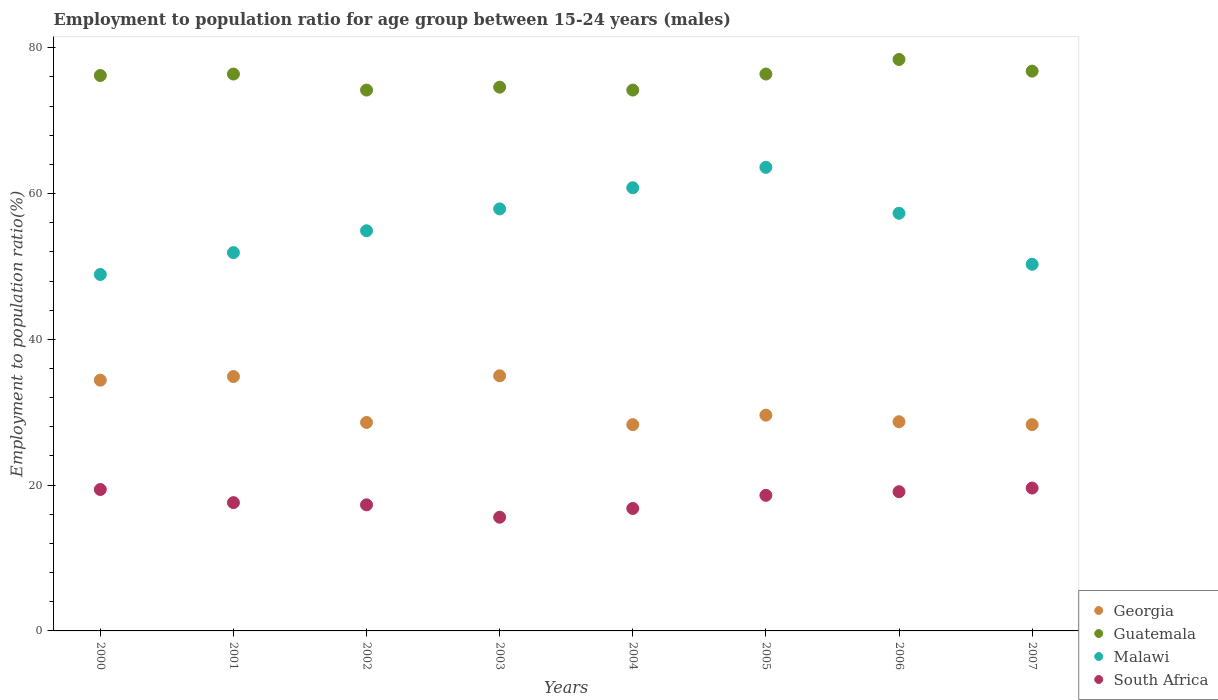Is the number of dotlines equal to the number of legend labels?
Ensure brevity in your answer.  Yes. What is the employment to population ratio in Guatemala in 2005?
Provide a short and direct response. 76.4. Across all years, what is the maximum employment to population ratio in Georgia?
Your response must be concise. 35. Across all years, what is the minimum employment to population ratio in Guatemala?
Provide a succinct answer. 74.2. In which year was the employment to population ratio in Guatemala maximum?
Keep it short and to the point. 2006. In which year was the employment to population ratio in Guatemala minimum?
Your response must be concise. 2002. What is the total employment to population ratio in Malawi in the graph?
Offer a very short reply. 445.6. What is the difference between the employment to population ratio in Malawi in 2004 and that in 2007?
Give a very brief answer. 10.5. What is the difference between the employment to population ratio in South Africa in 2000 and the employment to population ratio in Malawi in 2007?
Provide a short and direct response. -30.9. What is the average employment to population ratio in Malawi per year?
Your answer should be compact. 55.7. In the year 2004, what is the difference between the employment to population ratio in South Africa and employment to population ratio in Guatemala?
Give a very brief answer. -57.4. What is the ratio of the employment to population ratio in Guatemala in 2000 to that in 2005?
Offer a terse response. 1. Is the employment to population ratio in Guatemala in 2001 less than that in 2003?
Your answer should be compact. No. What is the difference between the highest and the second highest employment to population ratio in Georgia?
Keep it short and to the point. 0.1. What is the difference between the highest and the lowest employment to population ratio in South Africa?
Make the answer very short. 4. In how many years, is the employment to population ratio in Guatemala greater than the average employment to population ratio in Guatemala taken over all years?
Offer a terse response. 5. Is the sum of the employment to population ratio in Guatemala in 2001 and 2005 greater than the maximum employment to population ratio in South Africa across all years?
Make the answer very short. Yes. Is it the case that in every year, the sum of the employment to population ratio in Georgia and employment to population ratio in South Africa  is greater than the employment to population ratio in Guatemala?
Your answer should be very brief. No. Does the employment to population ratio in Malawi monotonically increase over the years?
Make the answer very short. No. Is the employment to population ratio in South Africa strictly greater than the employment to population ratio in Malawi over the years?
Give a very brief answer. No. Is the employment to population ratio in Guatemala strictly less than the employment to population ratio in Malawi over the years?
Offer a terse response. No. How many years are there in the graph?
Your answer should be compact. 8. Does the graph contain grids?
Ensure brevity in your answer.  No. Where does the legend appear in the graph?
Your response must be concise. Bottom right. How are the legend labels stacked?
Make the answer very short. Vertical. What is the title of the graph?
Provide a short and direct response. Employment to population ratio for age group between 15-24 years (males). Does "Japan" appear as one of the legend labels in the graph?
Ensure brevity in your answer.  No. What is the label or title of the X-axis?
Offer a very short reply. Years. What is the Employment to population ratio(%) of Georgia in 2000?
Provide a succinct answer. 34.4. What is the Employment to population ratio(%) of Guatemala in 2000?
Provide a short and direct response. 76.2. What is the Employment to population ratio(%) in Malawi in 2000?
Your answer should be very brief. 48.9. What is the Employment to population ratio(%) in South Africa in 2000?
Offer a terse response. 19.4. What is the Employment to population ratio(%) in Georgia in 2001?
Make the answer very short. 34.9. What is the Employment to population ratio(%) in Guatemala in 2001?
Provide a succinct answer. 76.4. What is the Employment to population ratio(%) of Malawi in 2001?
Make the answer very short. 51.9. What is the Employment to population ratio(%) of South Africa in 2001?
Ensure brevity in your answer.  17.6. What is the Employment to population ratio(%) in Georgia in 2002?
Provide a short and direct response. 28.6. What is the Employment to population ratio(%) of Guatemala in 2002?
Offer a terse response. 74.2. What is the Employment to population ratio(%) of Malawi in 2002?
Your response must be concise. 54.9. What is the Employment to population ratio(%) of South Africa in 2002?
Offer a terse response. 17.3. What is the Employment to population ratio(%) of Guatemala in 2003?
Provide a short and direct response. 74.6. What is the Employment to population ratio(%) in Malawi in 2003?
Give a very brief answer. 57.9. What is the Employment to population ratio(%) in South Africa in 2003?
Your answer should be very brief. 15.6. What is the Employment to population ratio(%) of Georgia in 2004?
Provide a succinct answer. 28.3. What is the Employment to population ratio(%) in Guatemala in 2004?
Keep it short and to the point. 74.2. What is the Employment to population ratio(%) of Malawi in 2004?
Provide a succinct answer. 60.8. What is the Employment to population ratio(%) in South Africa in 2004?
Offer a very short reply. 16.8. What is the Employment to population ratio(%) in Georgia in 2005?
Your response must be concise. 29.6. What is the Employment to population ratio(%) of Guatemala in 2005?
Offer a terse response. 76.4. What is the Employment to population ratio(%) in Malawi in 2005?
Keep it short and to the point. 63.6. What is the Employment to population ratio(%) of South Africa in 2005?
Provide a short and direct response. 18.6. What is the Employment to population ratio(%) in Georgia in 2006?
Ensure brevity in your answer.  28.7. What is the Employment to population ratio(%) in Guatemala in 2006?
Your answer should be compact. 78.4. What is the Employment to population ratio(%) in Malawi in 2006?
Provide a succinct answer. 57.3. What is the Employment to population ratio(%) of South Africa in 2006?
Make the answer very short. 19.1. What is the Employment to population ratio(%) in Georgia in 2007?
Give a very brief answer. 28.3. What is the Employment to population ratio(%) of Guatemala in 2007?
Ensure brevity in your answer.  76.8. What is the Employment to population ratio(%) in Malawi in 2007?
Provide a short and direct response. 50.3. What is the Employment to population ratio(%) in South Africa in 2007?
Keep it short and to the point. 19.6. Across all years, what is the maximum Employment to population ratio(%) in Guatemala?
Ensure brevity in your answer.  78.4. Across all years, what is the maximum Employment to population ratio(%) in Malawi?
Give a very brief answer. 63.6. Across all years, what is the maximum Employment to population ratio(%) of South Africa?
Provide a short and direct response. 19.6. Across all years, what is the minimum Employment to population ratio(%) of Georgia?
Your answer should be very brief. 28.3. Across all years, what is the minimum Employment to population ratio(%) of Guatemala?
Give a very brief answer. 74.2. Across all years, what is the minimum Employment to population ratio(%) of Malawi?
Your answer should be compact. 48.9. Across all years, what is the minimum Employment to population ratio(%) in South Africa?
Provide a short and direct response. 15.6. What is the total Employment to population ratio(%) of Georgia in the graph?
Give a very brief answer. 247.8. What is the total Employment to population ratio(%) of Guatemala in the graph?
Keep it short and to the point. 607.2. What is the total Employment to population ratio(%) of Malawi in the graph?
Your answer should be compact. 445.6. What is the total Employment to population ratio(%) of South Africa in the graph?
Your answer should be compact. 144. What is the difference between the Employment to population ratio(%) in Georgia in 2000 and that in 2001?
Give a very brief answer. -0.5. What is the difference between the Employment to population ratio(%) of Malawi in 2000 and that in 2001?
Provide a succinct answer. -3. What is the difference between the Employment to population ratio(%) of South Africa in 2000 and that in 2001?
Make the answer very short. 1.8. What is the difference between the Employment to population ratio(%) of Georgia in 2000 and that in 2002?
Your response must be concise. 5.8. What is the difference between the Employment to population ratio(%) of Malawi in 2000 and that in 2002?
Offer a terse response. -6. What is the difference between the Employment to population ratio(%) of Georgia in 2000 and that in 2003?
Offer a terse response. -0.6. What is the difference between the Employment to population ratio(%) of Malawi in 2000 and that in 2003?
Provide a short and direct response. -9. What is the difference between the Employment to population ratio(%) in Georgia in 2000 and that in 2004?
Provide a short and direct response. 6.1. What is the difference between the Employment to population ratio(%) of Guatemala in 2000 and that in 2004?
Your answer should be compact. 2. What is the difference between the Employment to population ratio(%) of Malawi in 2000 and that in 2004?
Your answer should be compact. -11.9. What is the difference between the Employment to population ratio(%) of Georgia in 2000 and that in 2005?
Offer a very short reply. 4.8. What is the difference between the Employment to population ratio(%) of Malawi in 2000 and that in 2005?
Offer a terse response. -14.7. What is the difference between the Employment to population ratio(%) of South Africa in 2000 and that in 2005?
Your answer should be very brief. 0.8. What is the difference between the Employment to population ratio(%) in Guatemala in 2000 and that in 2006?
Offer a very short reply. -2.2. What is the difference between the Employment to population ratio(%) in South Africa in 2000 and that in 2006?
Offer a very short reply. 0.3. What is the difference between the Employment to population ratio(%) of Guatemala in 2000 and that in 2007?
Give a very brief answer. -0.6. What is the difference between the Employment to population ratio(%) of South Africa in 2000 and that in 2007?
Keep it short and to the point. -0.2. What is the difference between the Employment to population ratio(%) in Guatemala in 2001 and that in 2002?
Your answer should be very brief. 2.2. What is the difference between the Employment to population ratio(%) in Malawi in 2001 and that in 2002?
Make the answer very short. -3. What is the difference between the Employment to population ratio(%) of South Africa in 2001 and that in 2002?
Keep it short and to the point. 0.3. What is the difference between the Employment to population ratio(%) in Georgia in 2001 and that in 2003?
Make the answer very short. -0.1. What is the difference between the Employment to population ratio(%) of Malawi in 2001 and that in 2003?
Make the answer very short. -6. What is the difference between the Employment to population ratio(%) in Georgia in 2001 and that in 2004?
Your answer should be very brief. 6.6. What is the difference between the Employment to population ratio(%) in South Africa in 2001 and that in 2004?
Ensure brevity in your answer.  0.8. What is the difference between the Employment to population ratio(%) of Georgia in 2001 and that in 2005?
Keep it short and to the point. 5.3. What is the difference between the Employment to population ratio(%) in Malawi in 2001 and that in 2005?
Your response must be concise. -11.7. What is the difference between the Employment to population ratio(%) of Guatemala in 2001 and that in 2006?
Your response must be concise. -2. What is the difference between the Employment to population ratio(%) in Malawi in 2001 and that in 2006?
Your answer should be compact. -5.4. What is the difference between the Employment to population ratio(%) of Guatemala in 2001 and that in 2007?
Keep it short and to the point. -0.4. What is the difference between the Employment to population ratio(%) of Georgia in 2002 and that in 2003?
Make the answer very short. -6.4. What is the difference between the Employment to population ratio(%) of Guatemala in 2002 and that in 2003?
Provide a short and direct response. -0.4. What is the difference between the Employment to population ratio(%) in Malawi in 2002 and that in 2003?
Your answer should be very brief. -3. What is the difference between the Employment to population ratio(%) in South Africa in 2002 and that in 2003?
Provide a succinct answer. 1.7. What is the difference between the Employment to population ratio(%) in Malawi in 2002 and that in 2004?
Make the answer very short. -5.9. What is the difference between the Employment to population ratio(%) of South Africa in 2002 and that in 2004?
Give a very brief answer. 0.5. What is the difference between the Employment to population ratio(%) in Guatemala in 2002 and that in 2005?
Give a very brief answer. -2.2. What is the difference between the Employment to population ratio(%) in Malawi in 2002 and that in 2005?
Ensure brevity in your answer.  -8.7. What is the difference between the Employment to population ratio(%) in South Africa in 2002 and that in 2005?
Ensure brevity in your answer.  -1.3. What is the difference between the Employment to population ratio(%) of Georgia in 2002 and that in 2006?
Your answer should be very brief. -0.1. What is the difference between the Employment to population ratio(%) of Guatemala in 2002 and that in 2006?
Provide a short and direct response. -4.2. What is the difference between the Employment to population ratio(%) in Georgia in 2002 and that in 2007?
Ensure brevity in your answer.  0.3. What is the difference between the Employment to population ratio(%) of Guatemala in 2002 and that in 2007?
Your answer should be compact. -2.6. What is the difference between the Employment to population ratio(%) in Malawi in 2002 and that in 2007?
Offer a terse response. 4.6. What is the difference between the Employment to population ratio(%) of Malawi in 2003 and that in 2004?
Your answer should be compact. -2.9. What is the difference between the Employment to population ratio(%) of Georgia in 2003 and that in 2005?
Provide a succinct answer. 5.4. What is the difference between the Employment to population ratio(%) in Guatemala in 2003 and that in 2005?
Provide a succinct answer. -1.8. What is the difference between the Employment to population ratio(%) of Malawi in 2003 and that in 2005?
Make the answer very short. -5.7. What is the difference between the Employment to population ratio(%) in Guatemala in 2003 and that in 2006?
Offer a terse response. -3.8. What is the difference between the Employment to population ratio(%) in South Africa in 2003 and that in 2006?
Ensure brevity in your answer.  -3.5. What is the difference between the Employment to population ratio(%) in Georgia in 2003 and that in 2007?
Ensure brevity in your answer.  6.7. What is the difference between the Employment to population ratio(%) of Malawi in 2003 and that in 2007?
Offer a very short reply. 7.6. What is the difference between the Employment to population ratio(%) of Georgia in 2004 and that in 2005?
Offer a terse response. -1.3. What is the difference between the Employment to population ratio(%) in Guatemala in 2004 and that in 2005?
Offer a very short reply. -2.2. What is the difference between the Employment to population ratio(%) in South Africa in 2004 and that in 2005?
Your response must be concise. -1.8. What is the difference between the Employment to population ratio(%) of Georgia in 2004 and that in 2006?
Provide a short and direct response. -0.4. What is the difference between the Employment to population ratio(%) of Malawi in 2004 and that in 2006?
Provide a succinct answer. 3.5. What is the difference between the Employment to population ratio(%) of South Africa in 2004 and that in 2007?
Give a very brief answer. -2.8. What is the difference between the Employment to population ratio(%) of Georgia in 2005 and that in 2006?
Your response must be concise. 0.9. What is the difference between the Employment to population ratio(%) in Guatemala in 2005 and that in 2006?
Your answer should be very brief. -2. What is the difference between the Employment to population ratio(%) of Malawi in 2005 and that in 2006?
Keep it short and to the point. 6.3. What is the difference between the Employment to population ratio(%) in Georgia in 2005 and that in 2007?
Your response must be concise. 1.3. What is the difference between the Employment to population ratio(%) in Georgia in 2006 and that in 2007?
Give a very brief answer. 0.4. What is the difference between the Employment to population ratio(%) in Guatemala in 2006 and that in 2007?
Your response must be concise. 1.6. What is the difference between the Employment to population ratio(%) in Malawi in 2006 and that in 2007?
Provide a short and direct response. 7. What is the difference between the Employment to population ratio(%) of Georgia in 2000 and the Employment to population ratio(%) of Guatemala in 2001?
Provide a succinct answer. -42. What is the difference between the Employment to population ratio(%) in Georgia in 2000 and the Employment to population ratio(%) in Malawi in 2001?
Offer a terse response. -17.5. What is the difference between the Employment to population ratio(%) in Guatemala in 2000 and the Employment to population ratio(%) in Malawi in 2001?
Keep it short and to the point. 24.3. What is the difference between the Employment to population ratio(%) of Guatemala in 2000 and the Employment to population ratio(%) of South Africa in 2001?
Ensure brevity in your answer.  58.6. What is the difference between the Employment to population ratio(%) of Malawi in 2000 and the Employment to population ratio(%) of South Africa in 2001?
Offer a very short reply. 31.3. What is the difference between the Employment to population ratio(%) of Georgia in 2000 and the Employment to population ratio(%) of Guatemala in 2002?
Provide a succinct answer. -39.8. What is the difference between the Employment to population ratio(%) in Georgia in 2000 and the Employment to population ratio(%) in Malawi in 2002?
Ensure brevity in your answer.  -20.5. What is the difference between the Employment to population ratio(%) in Guatemala in 2000 and the Employment to population ratio(%) in Malawi in 2002?
Your answer should be compact. 21.3. What is the difference between the Employment to population ratio(%) of Guatemala in 2000 and the Employment to population ratio(%) of South Africa in 2002?
Give a very brief answer. 58.9. What is the difference between the Employment to population ratio(%) in Malawi in 2000 and the Employment to population ratio(%) in South Africa in 2002?
Make the answer very short. 31.6. What is the difference between the Employment to population ratio(%) in Georgia in 2000 and the Employment to population ratio(%) in Guatemala in 2003?
Offer a terse response. -40.2. What is the difference between the Employment to population ratio(%) of Georgia in 2000 and the Employment to population ratio(%) of Malawi in 2003?
Your response must be concise. -23.5. What is the difference between the Employment to population ratio(%) of Georgia in 2000 and the Employment to population ratio(%) of South Africa in 2003?
Offer a very short reply. 18.8. What is the difference between the Employment to population ratio(%) of Guatemala in 2000 and the Employment to population ratio(%) of South Africa in 2003?
Provide a succinct answer. 60.6. What is the difference between the Employment to population ratio(%) in Malawi in 2000 and the Employment to population ratio(%) in South Africa in 2003?
Ensure brevity in your answer.  33.3. What is the difference between the Employment to population ratio(%) in Georgia in 2000 and the Employment to population ratio(%) in Guatemala in 2004?
Ensure brevity in your answer.  -39.8. What is the difference between the Employment to population ratio(%) of Georgia in 2000 and the Employment to population ratio(%) of Malawi in 2004?
Your answer should be very brief. -26.4. What is the difference between the Employment to population ratio(%) of Guatemala in 2000 and the Employment to population ratio(%) of Malawi in 2004?
Provide a succinct answer. 15.4. What is the difference between the Employment to population ratio(%) in Guatemala in 2000 and the Employment to population ratio(%) in South Africa in 2004?
Give a very brief answer. 59.4. What is the difference between the Employment to population ratio(%) in Malawi in 2000 and the Employment to population ratio(%) in South Africa in 2004?
Make the answer very short. 32.1. What is the difference between the Employment to population ratio(%) in Georgia in 2000 and the Employment to population ratio(%) in Guatemala in 2005?
Ensure brevity in your answer.  -42. What is the difference between the Employment to population ratio(%) of Georgia in 2000 and the Employment to population ratio(%) of Malawi in 2005?
Give a very brief answer. -29.2. What is the difference between the Employment to population ratio(%) in Guatemala in 2000 and the Employment to population ratio(%) in South Africa in 2005?
Give a very brief answer. 57.6. What is the difference between the Employment to population ratio(%) of Malawi in 2000 and the Employment to population ratio(%) of South Africa in 2005?
Your answer should be compact. 30.3. What is the difference between the Employment to population ratio(%) of Georgia in 2000 and the Employment to population ratio(%) of Guatemala in 2006?
Give a very brief answer. -44. What is the difference between the Employment to population ratio(%) of Georgia in 2000 and the Employment to population ratio(%) of Malawi in 2006?
Offer a very short reply. -22.9. What is the difference between the Employment to population ratio(%) in Georgia in 2000 and the Employment to population ratio(%) in South Africa in 2006?
Ensure brevity in your answer.  15.3. What is the difference between the Employment to population ratio(%) of Guatemala in 2000 and the Employment to population ratio(%) of South Africa in 2006?
Ensure brevity in your answer.  57.1. What is the difference between the Employment to population ratio(%) in Malawi in 2000 and the Employment to population ratio(%) in South Africa in 2006?
Offer a terse response. 29.8. What is the difference between the Employment to population ratio(%) of Georgia in 2000 and the Employment to population ratio(%) of Guatemala in 2007?
Provide a succinct answer. -42.4. What is the difference between the Employment to population ratio(%) in Georgia in 2000 and the Employment to population ratio(%) in Malawi in 2007?
Your answer should be compact. -15.9. What is the difference between the Employment to population ratio(%) in Guatemala in 2000 and the Employment to population ratio(%) in Malawi in 2007?
Your response must be concise. 25.9. What is the difference between the Employment to population ratio(%) of Guatemala in 2000 and the Employment to population ratio(%) of South Africa in 2007?
Provide a short and direct response. 56.6. What is the difference between the Employment to population ratio(%) in Malawi in 2000 and the Employment to population ratio(%) in South Africa in 2007?
Ensure brevity in your answer.  29.3. What is the difference between the Employment to population ratio(%) in Georgia in 2001 and the Employment to population ratio(%) in Guatemala in 2002?
Your response must be concise. -39.3. What is the difference between the Employment to population ratio(%) of Georgia in 2001 and the Employment to population ratio(%) of Malawi in 2002?
Your response must be concise. -20. What is the difference between the Employment to population ratio(%) in Guatemala in 2001 and the Employment to population ratio(%) in Malawi in 2002?
Offer a very short reply. 21.5. What is the difference between the Employment to population ratio(%) of Guatemala in 2001 and the Employment to population ratio(%) of South Africa in 2002?
Your answer should be compact. 59.1. What is the difference between the Employment to population ratio(%) of Malawi in 2001 and the Employment to population ratio(%) of South Africa in 2002?
Provide a succinct answer. 34.6. What is the difference between the Employment to population ratio(%) of Georgia in 2001 and the Employment to population ratio(%) of Guatemala in 2003?
Provide a short and direct response. -39.7. What is the difference between the Employment to population ratio(%) in Georgia in 2001 and the Employment to population ratio(%) in Malawi in 2003?
Your answer should be compact. -23. What is the difference between the Employment to population ratio(%) in Georgia in 2001 and the Employment to population ratio(%) in South Africa in 2003?
Keep it short and to the point. 19.3. What is the difference between the Employment to population ratio(%) of Guatemala in 2001 and the Employment to population ratio(%) of South Africa in 2003?
Your response must be concise. 60.8. What is the difference between the Employment to population ratio(%) in Malawi in 2001 and the Employment to population ratio(%) in South Africa in 2003?
Your response must be concise. 36.3. What is the difference between the Employment to population ratio(%) of Georgia in 2001 and the Employment to population ratio(%) of Guatemala in 2004?
Keep it short and to the point. -39.3. What is the difference between the Employment to population ratio(%) of Georgia in 2001 and the Employment to population ratio(%) of Malawi in 2004?
Make the answer very short. -25.9. What is the difference between the Employment to population ratio(%) in Georgia in 2001 and the Employment to population ratio(%) in South Africa in 2004?
Ensure brevity in your answer.  18.1. What is the difference between the Employment to population ratio(%) in Guatemala in 2001 and the Employment to population ratio(%) in South Africa in 2004?
Your response must be concise. 59.6. What is the difference between the Employment to population ratio(%) of Malawi in 2001 and the Employment to population ratio(%) of South Africa in 2004?
Provide a short and direct response. 35.1. What is the difference between the Employment to population ratio(%) of Georgia in 2001 and the Employment to population ratio(%) of Guatemala in 2005?
Provide a short and direct response. -41.5. What is the difference between the Employment to population ratio(%) of Georgia in 2001 and the Employment to population ratio(%) of Malawi in 2005?
Make the answer very short. -28.7. What is the difference between the Employment to population ratio(%) of Guatemala in 2001 and the Employment to population ratio(%) of South Africa in 2005?
Provide a short and direct response. 57.8. What is the difference between the Employment to population ratio(%) in Malawi in 2001 and the Employment to population ratio(%) in South Africa in 2005?
Give a very brief answer. 33.3. What is the difference between the Employment to population ratio(%) in Georgia in 2001 and the Employment to population ratio(%) in Guatemala in 2006?
Offer a terse response. -43.5. What is the difference between the Employment to population ratio(%) of Georgia in 2001 and the Employment to population ratio(%) of Malawi in 2006?
Keep it short and to the point. -22.4. What is the difference between the Employment to population ratio(%) of Georgia in 2001 and the Employment to population ratio(%) of South Africa in 2006?
Your response must be concise. 15.8. What is the difference between the Employment to population ratio(%) of Guatemala in 2001 and the Employment to population ratio(%) of Malawi in 2006?
Offer a very short reply. 19.1. What is the difference between the Employment to population ratio(%) in Guatemala in 2001 and the Employment to population ratio(%) in South Africa in 2006?
Provide a short and direct response. 57.3. What is the difference between the Employment to population ratio(%) in Malawi in 2001 and the Employment to population ratio(%) in South Africa in 2006?
Keep it short and to the point. 32.8. What is the difference between the Employment to population ratio(%) in Georgia in 2001 and the Employment to population ratio(%) in Guatemala in 2007?
Ensure brevity in your answer.  -41.9. What is the difference between the Employment to population ratio(%) in Georgia in 2001 and the Employment to population ratio(%) in Malawi in 2007?
Give a very brief answer. -15.4. What is the difference between the Employment to population ratio(%) in Georgia in 2001 and the Employment to population ratio(%) in South Africa in 2007?
Your answer should be compact. 15.3. What is the difference between the Employment to population ratio(%) in Guatemala in 2001 and the Employment to population ratio(%) in Malawi in 2007?
Ensure brevity in your answer.  26.1. What is the difference between the Employment to population ratio(%) in Guatemala in 2001 and the Employment to population ratio(%) in South Africa in 2007?
Offer a very short reply. 56.8. What is the difference between the Employment to population ratio(%) in Malawi in 2001 and the Employment to population ratio(%) in South Africa in 2007?
Keep it short and to the point. 32.3. What is the difference between the Employment to population ratio(%) of Georgia in 2002 and the Employment to population ratio(%) of Guatemala in 2003?
Offer a terse response. -46. What is the difference between the Employment to population ratio(%) of Georgia in 2002 and the Employment to population ratio(%) of Malawi in 2003?
Provide a short and direct response. -29.3. What is the difference between the Employment to population ratio(%) of Georgia in 2002 and the Employment to population ratio(%) of South Africa in 2003?
Offer a very short reply. 13. What is the difference between the Employment to population ratio(%) of Guatemala in 2002 and the Employment to population ratio(%) of Malawi in 2003?
Your response must be concise. 16.3. What is the difference between the Employment to population ratio(%) of Guatemala in 2002 and the Employment to population ratio(%) of South Africa in 2003?
Provide a succinct answer. 58.6. What is the difference between the Employment to population ratio(%) in Malawi in 2002 and the Employment to population ratio(%) in South Africa in 2003?
Your answer should be very brief. 39.3. What is the difference between the Employment to population ratio(%) of Georgia in 2002 and the Employment to population ratio(%) of Guatemala in 2004?
Give a very brief answer. -45.6. What is the difference between the Employment to population ratio(%) in Georgia in 2002 and the Employment to population ratio(%) in Malawi in 2004?
Ensure brevity in your answer.  -32.2. What is the difference between the Employment to population ratio(%) of Georgia in 2002 and the Employment to population ratio(%) of South Africa in 2004?
Your response must be concise. 11.8. What is the difference between the Employment to population ratio(%) in Guatemala in 2002 and the Employment to population ratio(%) in South Africa in 2004?
Provide a succinct answer. 57.4. What is the difference between the Employment to population ratio(%) in Malawi in 2002 and the Employment to population ratio(%) in South Africa in 2004?
Your answer should be very brief. 38.1. What is the difference between the Employment to population ratio(%) of Georgia in 2002 and the Employment to population ratio(%) of Guatemala in 2005?
Provide a short and direct response. -47.8. What is the difference between the Employment to population ratio(%) in Georgia in 2002 and the Employment to population ratio(%) in Malawi in 2005?
Make the answer very short. -35. What is the difference between the Employment to population ratio(%) of Georgia in 2002 and the Employment to population ratio(%) of South Africa in 2005?
Provide a short and direct response. 10. What is the difference between the Employment to population ratio(%) in Guatemala in 2002 and the Employment to population ratio(%) in South Africa in 2005?
Provide a succinct answer. 55.6. What is the difference between the Employment to population ratio(%) of Malawi in 2002 and the Employment to population ratio(%) of South Africa in 2005?
Make the answer very short. 36.3. What is the difference between the Employment to population ratio(%) of Georgia in 2002 and the Employment to population ratio(%) of Guatemala in 2006?
Your response must be concise. -49.8. What is the difference between the Employment to population ratio(%) of Georgia in 2002 and the Employment to population ratio(%) of Malawi in 2006?
Provide a short and direct response. -28.7. What is the difference between the Employment to population ratio(%) of Georgia in 2002 and the Employment to population ratio(%) of South Africa in 2006?
Keep it short and to the point. 9.5. What is the difference between the Employment to population ratio(%) of Guatemala in 2002 and the Employment to population ratio(%) of South Africa in 2006?
Provide a succinct answer. 55.1. What is the difference between the Employment to population ratio(%) of Malawi in 2002 and the Employment to population ratio(%) of South Africa in 2006?
Provide a short and direct response. 35.8. What is the difference between the Employment to population ratio(%) of Georgia in 2002 and the Employment to population ratio(%) of Guatemala in 2007?
Keep it short and to the point. -48.2. What is the difference between the Employment to population ratio(%) in Georgia in 2002 and the Employment to population ratio(%) in Malawi in 2007?
Offer a terse response. -21.7. What is the difference between the Employment to population ratio(%) in Georgia in 2002 and the Employment to population ratio(%) in South Africa in 2007?
Offer a terse response. 9. What is the difference between the Employment to population ratio(%) in Guatemala in 2002 and the Employment to population ratio(%) in Malawi in 2007?
Your answer should be compact. 23.9. What is the difference between the Employment to population ratio(%) of Guatemala in 2002 and the Employment to population ratio(%) of South Africa in 2007?
Your response must be concise. 54.6. What is the difference between the Employment to population ratio(%) in Malawi in 2002 and the Employment to population ratio(%) in South Africa in 2007?
Make the answer very short. 35.3. What is the difference between the Employment to population ratio(%) of Georgia in 2003 and the Employment to population ratio(%) of Guatemala in 2004?
Your response must be concise. -39.2. What is the difference between the Employment to population ratio(%) of Georgia in 2003 and the Employment to population ratio(%) of Malawi in 2004?
Your answer should be compact. -25.8. What is the difference between the Employment to population ratio(%) in Guatemala in 2003 and the Employment to population ratio(%) in South Africa in 2004?
Offer a very short reply. 57.8. What is the difference between the Employment to population ratio(%) in Malawi in 2003 and the Employment to population ratio(%) in South Africa in 2004?
Offer a very short reply. 41.1. What is the difference between the Employment to population ratio(%) in Georgia in 2003 and the Employment to population ratio(%) in Guatemala in 2005?
Your answer should be compact. -41.4. What is the difference between the Employment to population ratio(%) of Georgia in 2003 and the Employment to population ratio(%) of Malawi in 2005?
Your response must be concise. -28.6. What is the difference between the Employment to population ratio(%) of Georgia in 2003 and the Employment to population ratio(%) of South Africa in 2005?
Provide a short and direct response. 16.4. What is the difference between the Employment to population ratio(%) in Guatemala in 2003 and the Employment to population ratio(%) in Malawi in 2005?
Keep it short and to the point. 11. What is the difference between the Employment to population ratio(%) of Guatemala in 2003 and the Employment to population ratio(%) of South Africa in 2005?
Provide a short and direct response. 56. What is the difference between the Employment to population ratio(%) in Malawi in 2003 and the Employment to population ratio(%) in South Africa in 2005?
Offer a terse response. 39.3. What is the difference between the Employment to population ratio(%) of Georgia in 2003 and the Employment to population ratio(%) of Guatemala in 2006?
Provide a short and direct response. -43.4. What is the difference between the Employment to population ratio(%) in Georgia in 2003 and the Employment to population ratio(%) in Malawi in 2006?
Provide a short and direct response. -22.3. What is the difference between the Employment to population ratio(%) of Georgia in 2003 and the Employment to population ratio(%) of South Africa in 2006?
Give a very brief answer. 15.9. What is the difference between the Employment to population ratio(%) of Guatemala in 2003 and the Employment to population ratio(%) of South Africa in 2006?
Offer a very short reply. 55.5. What is the difference between the Employment to population ratio(%) of Malawi in 2003 and the Employment to population ratio(%) of South Africa in 2006?
Offer a terse response. 38.8. What is the difference between the Employment to population ratio(%) of Georgia in 2003 and the Employment to population ratio(%) of Guatemala in 2007?
Make the answer very short. -41.8. What is the difference between the Employment to population ratio(%) in Georgia in 2003 and the Employment to population ratio(%) in Malawi in 2007?
Make the answer very short. -15.3. What is the difference between the Employment to population ratio(%) of Georgia in 2003 and the Employment to population ratio(%) of South Africa in 2007?
Provide a short and direct response. 15.4. What is the difference between the Employment to population ratio(%) in Guatemala in 2003 and the Employment to population ratio(%) in Malawi in 2007?
Keep it short and to the point. 24.3. What is the difference between the Employment to population ratio(%) of Guatemala in 2003 and the Employment to population ratio(%) of South Africa in 2007?
Ensure brevity in your answer.  55. What is the difference between the Employment to population ratio(%) in Malawi in 2003 and the Employment to population ratio(%) in South Africa in 2007?
Your answer should be compact. 38.3. What is the difference between the Employment to population ratio(%) in Georgia in 2004 and the Employment to population ratio(%) in Guatemala in 2005?
Your answer should be compact. -48.1. What is the difference between the Employment to population ratio(%) of Georgia in 2004 and the Employment to population ratio(%) of Malawi in 2005?
Offer a terse response. -35.3. What is the difference between the Employment to population ratio(%) in Georgia in 2004 and the Employment to population ratio(%) in South Africa in 2005?
Provide a short and direct response. 9.7. What is the difference between the Employment to population ratio(%) of Guatemala in 2004 and the Employment to population ratio(%) of South Africa in 2005?
Offer a terse response. 55.6. What is the difference between the Employment to population ratio(%) of Malawi in 2004 and the Employment to population ratio(%) of South Africa in 2005?
Provide a short and direct response. 42.2. What is the difference between the Employment to population ratio(%) in Georgia in 2004 and the Employment to population ratio(%) in Guatemala in 2006?
Give a very brief answer. -50.1. What is the difference between the Employment to population ratio(%) of Georgia in 2004 and the Employment to population ratio(%) of Malawi in 2006?
Make the answer very short. -29. What is the difference between the Employment to population ratio(%) of Guatemala in 2004 and the Employment to population ratio(%) of South Africa in 2006?
Ensure brevity in your answer.  55.1. What is the difference between the Employment to population ratio(%) of Malawi in 2004 and the Employment to population ratio(%) of South Africa in 2006?
Make the answer very short. 41.7. What is the difference between the Employment to population ratio(%) in Georgia in 2004 and the Employment to population ratio(%) in Guatemala in 2007?
Your response must be concise. -48.5. What is the difference between the Employment to population ratio(%) in Georgia in 2004 and the Employment to population ratio(%) in Malawi in 2007?
Your answer should be compact. -22. What is the difference between the Employment to population ratio(%) of Georgia in 2004 and the Employment to population ratio(%) of South Africa in 2007?
Your response must be concise. 8.7. What is the difference between the Employment to population ratio(%) of Guatemala in 2004 and the Employment to population ratio(%) of Malawi in 2007?
Ensure brevity in your answer.  23.9. What is the difference between the Employment to population ratio(%) of Guatemala in 2004 and the Employment to population ratio(%) of South Africa in 2007?
Provide a short and direct response. 54.6. What is the difference between the Employment to population ratio(%) in Malawi in 2004 and the Employment to population ratio(%) in South Africa in 2007?
Ensure brevity in your answer.  41.2. What is the difference between the Employment to population ratio(%) in Georgia in 2005 and the Employment to population ratio(%) in Guatemala in 2006?
Make the answer very short. -48.8. What is the difference between the Employment to population ratio(%) in Georgia in 2005 and the Employment to population ratio(%) in Malawi in 2006?
Your answer should be very brief. -27.7. What is the difference between the Employment to population ratio(%) in Georgia in 2005 and the Employment to population ratio(%) in South Africa in 2006?
Your answer should be compact. 10.5. What is the difference between the Employment to population ratio(%) of Guatemala in 2005 and the Employment to population ratio(%) of South Africa in 2006?
Keep it short and to the point. 57.3. What is the difference between the Employment to population ratio(%) of Malawi in 2005 and the Employment to population ratio(%) of South Africa in 2006?
Make the answer very short. 44.5. What is the difference between the Employment to population ratio(%) of Georgia in 2005 and the Employment to population ratio(%) of Guatemala in 2007?
Your response must be concise. -47.2. What is the difference between the Employment to population ratio(%) in Georgia in 2005 and the Employment to population ratio(%) in Malawi in 2007?
Ensure brevity in your answer.  -20.7. What is the difference between the Employment to population ratio(%) of Guatemala in 2005 and the Employment to population ratio(%) of Malawi in 2007?
Make the answer very short. 26.1. What is the difference between the Employment to population ratio(%) in Guatemala in 2005 and the Employment to population ratio(%) in South Africa in 2007?
Offer a terse response. 56.8. What is the difference between the Employment to population ratio(%) in Georgia in 2006 and the Employment to population ratio(%) in Guatemala in 2007?
Offer a very short reply. -48.1. What is the difference between the Employment to population ratio(%) of Georgia in 2006 and the Employment to population ratio(%) of Malawi in 2007?
Provide a short and direct response. -21.6. What is the difference between the Employment to population ratio(%) of Georgia in 2006 and the Employment to population ratio(%) of South Africa in 2007?
Give a very brief answer. 9.1. What is the difference between the Employment to population ratio(%) in Guatemala in 2006 and the Employment to population ratio(%) in Malawi in 2007?
Your answer should be very brief. 28.1. What is the difference between the Employment to population ratio(%) in Guatemala in 2006 and the Employment to population ratio(%) in South Africa in 2007?
Your answer should be very brief. 58.8. What is the difference between the Employment to population ratio(%) in Malawi in 2006 and the Employment to population ratio(%) in South Africa in 2007?
Your answer should be compact. 37.7. What is the average Employment to population ratio(%) of Georgia per year?
Offer a very short reply. 30.98. What is the average Employment to population ratio(%) of Guatemala per year?
Make the answer very short. 75.9. What is the average Employment to population ratio(%) of Malawi per year?
Offer a very short reply. 55.7. In the year 2000, what is the difference between the Employment to population ratio(%) of Georgia and Employment to population ratio(%) of Guatemala?
Your response must be concise. -41.8. In the year 2000, what is the difference between the Employment to population ratio(%) of Georgia and Employment to population ratio(%) of Malawi?
Your response must be concise. -14.5. In the year 2000, what is the difference between the Employment to population ratio(%) of Georgia and Employment to population ratio(%) of South Africa?
Provide a succinct answer. 15. In the year 2000, what is the difference between the Employment to population ratio(%) of Guatemala and Employment to population ratio(%) of Malawi?
Make the answer very short. 27.3. In the year 2000, what is the difference between the Employment to population ratio(%) of Guatemala and Employment to population ratio(%) of South Africa?
Your answer should be compact. 56.8. In the year 2000, what is the difference between the Employment to population ratio(%) of Malawi and Employment to population ratio(%) of South Africa?
Provide a succinct answer. 29.5. In the year 2001, what is the difference between the Employment to population ratio(%) of Georgia and Employment to population ratio(%) of Guatemala?
Provide a short and direct response. -41.5. In the year 2001, what is the difference between the Employment to population ratio(%) in Georgia and Employment to population ratio(%) in Malawi?
Your answer should be very brief. -17. In the year 2001, what is the difference between the Employment to population ratio(%) in Georgia and Employment to population ratio(%) in South Africa?
Ensure brevity in your answer.  17.3. In the year 2001, what is the difference between the Employment to population ratio(%) in Guatemala and Employment to population ratio(%) in South Africa?
Ensure brevity in your answer.  58.8. In the year 2001, what is the difference between the Employment to population ratio(%) in Malawi and Employment to population ratio(%) in South Africa?
Your response must be concise. 34.3. In the year 2002, what is the difference between the Employment to population ratio(%) of Georgia and Employment to population ratio(%) of Guatemala?
Provide a succinct answer. -45.6. In the year 2002, what is the difference between the Employment to population ratio(%) of Georgia and Employment to population ratio(%) of Malawi?
Provide a short and direct response. -26.3. In the year 2002, what is the difference between the Employment to population ratio(%) of Georgia and Employment to population ratio(%) of South Africa?
Provide a short and direct response. 11.3. In the year 2002, what is the difference between the Employment to population ratio(%) of Guatemala and Employment to population ratio(%) of Malawi?
Your answer should be compact. 19.3. In the year 2002, what is the difference between the Employment to population ratio(%) of Guatemala and Employment to population ratio(%) of South Africa?
Your answer should be compact. 56.9. In the year 2002, what is the difference between the Employment to population ratio(%) in Malawi and Employment to population ratio(%) in South Africa?
Provide a short and direct response. 37.6. In the year 2003, what is the difference between the Employment to population ratio(%) of Georgia and Employment to population ratio(%) of Guatemala?
Ensure brevity in your answer.  -39.6. In the year 2003, what is the difference between the Employment to population ratio(%) in Georgia and Employment to population ratio(%) in Malawi?
Your answer should be very brief. -22.9. In the year 2003, what is the difference between the Employment to population ratio(%) of Georgia and Employment to population ratio(%) of South Africa?
Your answer should be compact. 19.4. In the year 2003, what is the difference between the Employment to population ratio(%) in Guatemala and Employment to population ratio(%) in Malawi?
Provide a succinct answer. 16.7. In the year 2003, what is the difference between the Employment to population ratio(%) in Guatemala and Employment to population ratio(%) in South Africa?
Give a very brief answer. 59. In the year 2003, what is the difference between the Employment to population ratio(%) of Malawi and Employment to population ratio(%) of South Africa?
Provide a succinct answer. 42.3. In the year 2004, what is the difference between the Employment to population ratio(%) in Georgia and Employment to population ratio(%) in Guatemala?
Keep it short and to the point. -45.9. In the year 2004, what is the difference between the Employment to population ratio(%) in Georgia and Employment to population ratio(%) in Malawi?
Make the answer very short. -32.5. In the year 2004, what is the difference between the Employment to population ratio(%) of Georgia and Employment to population ratio(%) of South Africa?
Provide a succinct answer. 11.5. In the year 2004, what is the difference between the Employment to population ratio(%) in Guatemala and Employment to population ratio(%) in Malawi?
Your answer should be compact. 13.4. In the year 2004, what is the difference between the Employment to population ratio(%) in Guatemala and Employment to population ratio(%) in South Africa?
Make the answer very short. 57.4. In the year 2005, what is the difference between the Employment to population ratio(%) in Georgia and Employment to population ratio(%) in Guatemala?
Offer a terse response. -46.8. In the year 2005, what is the difference between the Employment to population ratio(%) in Georgia and Employment to population ratio(%) in Malawi?
Your answer should be compact. -34. In the year 2005, what is the difference between the Employment to population ratio(%) in Georgia and Employment to population ratio(%) in South Africa?
Provide a short and direct response. 11. In the year 2005, what is the difference between the Employment to population ratio(%) in Guatemala and Employment to population ratio(%) in South Africa?
Your answer should be very brief. 57.8. In the year 2005, what is the difference between the Employment to population ratio(%) in Malawi and Employment to population ratio(%) in South Africa?
Provide a succinct answer. 45. In the year 2006, what is the difference between the Employment to population ratio(%) of Georgia and Employment to population ratio(%) of Guatemala?
Make the answer very short. -49.7. In the year 2006, what is the difference between the Employment to population ratio(%) of Georgia and Employment to population ratio(%) of Malawi?
Provide a succinct answer. -28.6. In the year 2006, what is the difference between the Employment to population ratio(%) in Guatemala and Employment to population ratio(%) in Malawi?
Provide a short and direct response. 21.1. In the year 2006, what is the difference between the Employment to population ratio(%) in Guatemala and Employment to population ratio(%) in South Africa?
Give a very brief answer. 59.3. In the year 2006, what is the difference between the Employment to population ratio(%) of Malawi and Employment to population ratio(%) of South Africa?
Offer a very short reply. 38.2. In the year 2007, what is the difference between the Employment to population ratio(%) of Georgia and Employment to population ratio(%) of Guatemala?
Provide a short and direct response. -48.5. In the year 2007, what is the difference between the Employment to population ratio(%) in Guatemala and Employment to population ratio(%) in Malawi?
Your answer should be compact. 26.5. In the year 2007, what is the difference between the Employment to population ratio(%) of Guatemala and Employment to population ratio(%) of South Africa?
Make the answer very short. 57.2. In the year 2007, what is the difference between the Employment to population ratio(%) of Malawi and Employment to population ratio(%) of South Africa?
Provide a succinct answer. 30.7. What is the ratio of the Employment to population ratio(%) of Georgia in 2000 to that in 2001?
Keep it short and to the point. 0.99. What is the ratio of the Employment to population ratio(%) in Guatemala in 2000 to that in 2001?
Make the answer very short. 1. What is the ratio of the Employment to population ratio(%) of Malawi in 2000 to that in 2001?
Make the answer very short. 0.94. What is the ratio of the Employment to population ratio(%) of South Africa in 2000 to that in 2001?
Ensure brevity in your answer.  1.1. What is the ratio of the Employment to population ratio(%) in Georgia in 2000 to that in 2002?
Offer a very short reply. 1.2. What is the ratio of the Employment to population ratio(%) in Malawi in 2000 to that in 2002?
Your answer should be very brief. 0.89. What is the ratio of the Employment to population ratio(%) of South Africa in 2000 to that in 2002?
Your answer should be compact. 1.12. What is the ratio of the Employment to population ratio(%) of Georgia in 2000 to that in 2003?
Your response must be concise. 0.98. What is the ratio of the Employment to population ratio(%) of Guatemala in 2000 to that in 2003?
Give a very brief answer. 1.02. What is the ratio of the Employment to population ratio(%) of Malawi in 2000 to that in 2003?
Make the answer very short. 0.84. What is the ratio of the Employment to population ratio(%) of South Africa in 2000 to that in 2003?
Offer a terse response. 1.24. What is the ratio of the Employment to population ratio(%) in Georgia in 2000 to that in 2004?
Give a very brief answer. 1.22. What is the ratio of the Employment to population ratio(%) in Malawi in 2000 to that in 2004?
Make the answer very short. 0.8. What is the ratio of the Employment to population ratio(%) in South Africa in 2000 to that in 2004?
Your answer should be compact. 1.15. What is the ratio of the Employment to population ratio(%) in Georgia in 2000 to that in 2005?
Provide a succinct answer. 1.16. What is the ratio of the Employment to population ratio(%) in Malawi in 2000 to that in 2005?
Your answer should be compact. 0.77. What is the ratio of the Employment to population ratio(%) of South Africa in 2000 to that in 2005?
Provide a succinct answer. 1.04. What is the ratio of the Employment to population ratio(%) in Georgia in 2000 to that in 2006?
Your response must be concise. 1.2. What is the ratio of the Employment to population ratio(%) of Guatemala in 2000 to that in 2006?
Your response must be concise. 0.97. What is the ratio of the Employment to population ratio(%) of Malawi in 2000 to that in 2006?
Keep it short and to the point. 0.85. What is the ratio of the Employment to population ratio(%) of South Africa in 2000 to that in 2006?
Ensure brevity in your answer.  1.02. What is the ratio of the Employment to population ratio(%) in Georgia in 2000 to that in 2007?
Your answer should be very brief. 1.22. What is the ratio of the Employment to population ratio(%) in Malawi in 2000 to that in 2007?
Offer a very short reply. 0.97. What is the ratio of the Employment to population ratio(%) in South Africa in 2000 to that in 2007?
Provide a short and direct response. 0.99. What is the ratio of the Employment to population ratio(%) of Georgia in 2001 to that in 2002?
Keep it short and to the point. 1.22. What is the ratio of the Employment to population ratio(%) in Guatemala in 2001 to that in 2002?
Your answer should be compact. 1.03. What is the ratio of the Employment to population ratio(%) of Malawi in 2001 to that in 2002?
Offer a terse response. 0.95. What is the ratio of the Employment to population ratio(%) of South Africa in 2001 to that in 2002?
Your answer should be very brief. 1.02. What is the ratio of the Employment to population ratio(%) of Georgia in 2001 to that in 2003?
Offer a terse response. 1. What is the ratio of the Employment to population ratio(%) of Guatemala in 2001 to that in 2003?
Provide a short and direct response. 1.02. What is the ratio of the Employment to population ratio(%) of Malawi in 2001 to that in 2003?
Offer a very short reply. 0.9. What is the ratio of the Employment to population ratio(%) in South Africa in 2001 to that in 2003?
Ensure brevity in your answer.  1.13. What is the ratio of the Employment to population ratio(%) of Georgia in 2001 to that in 2004?
Keep it short and to the point. 1.23. What is the ratio of the Employment to population ratio(%) of Guatemala in 2001 to that in 2004?
Provide a short and direct response. 1.03. What is the ratio of the Employment to population ratio(%) in Malawi in 2001 to that in 2004?
Offer a terse response. 0.85. What is the ratio of the Employment to population ratio(%) of South Africa in 2001 to that in 2004?
Your answer should be compact. 1.05. What is the ratio of the Employment to population ratio(%) of Georgia in 2001 to that in 2005?
Your answer should be very brief. 1.18. What is the ratio of the Employment to population ratio(%) in Malawi in 2001 to that in 2005?
Keep it short and to the point. 0.82. What is the ratio of the Employment to population ratio(%) in South Africa in 2001 to that in 2005?
Make the answer very short. 0.95. What is the ratio of the Employment to population ratio(%) of Georgia in 2001 to that in 2006?
Ensure brevity in your answer.  1.22. What is the ratio of the Employment to population ratio(%) of Guatemala in 2001 to that in 2006?
Give a very brief answer. 0.97. What is the ratio of the Employment to population ratio(%) in Malawi in 2001 to that in 2006?
Offer a very short reply. 0.91. What is the ratio of the Employment to population ratio(%) in South Africa in 2001 to that in 2006?
Offer a very short reply. 0.92. What is the ratio of the Employment to population ratio(%) of Georgia in 2001 to that in 2007?
Offer a very short reply. 1.23. What is the ratio of the Employment to population ratio(%) in Guatemala in 2001 to that in 2007?
Your answer should be compact. 0.99. What is the ratio of the Employment to population ratio(%) of Malawi in 2001 to that in 2007?
Provide a succinct answer. 1.03. What is the ratio of the Employment to population ratio(%) in South Africa in 2001 to that in 2007?
Provide a short and direct response. 0.9. What is the ratio of the Employment to population ratio(%) of Georgia in 2002 to that in 2003?
Your answer should be compact. 0.82. What is the ratio of the Employment to population ratio(%) of Guatemala in 2002 to that in 2003?
Your answer should be compact. 0.99. What is the ratio of the Employment to population ratio(%) of Malawi in 2002 to that in 2003?
Your answer should be compact. 0.95. What is the ratio of the Employment to population ratio(%) of South Africa in 2002 to that in 2003?
Give a very brief answer. 1.11. What is the ratio of the Employment to population ratio(%) of Georgia in 2002 to that in 2004?
Your answer should be compact. 1.01. What is the ratio of the Employment to population ratio(%) in Malawi in 2002 to that in 2004?
Your answer should be very brief. 0.9. What is the ratio of the Employment to population ratio(%) in South Africa in 2002 to that in 2004?
Give a very brief answer. 1.03. What is the ratio of the Employment to population ratio(%) in Georgia in 2002 to that in 2005?
Provide a succinct answer. 0.97. What is the ratio of the Employment to population ratio(%) of Guatemala in 2002 to that in 2005?
Give a very brief answer. 0.97. What is the ratio of the Employment to population ratio(%) of Malawi in 2002 to that in 2005?
Give a very brief answer. 0.86. What is the ratio of the Employment to population ratio(%) of South Africa in 2002 to that in 2005?
Give a very brief answer. 0.93. What is the ratio of the Employment to population ratio(%) of Guatemala in 2002 to that in 2006?
Give a very brief answer. 0.95. What is the ratio of the Employment to population ratio(%) in Malawi in 2002 to that in 2006?
Your answer should be very brief. 0.96. What is the ratio of the Employment to population ratio(%) of South Africa in 2002 to that in 2006?
Ensure brevity in your answer.  0.91. What is the ratio of the Employment to population ratio(%) in Georgia in 2002 to that in 2007?
Ensure brevity in your answer.  1.01. What is the ratio of the Employment to population ratio(%) in Guatemala in 2002 to that in 2007?
Offer a very short reply. 0.97. What is the ratio of the Employment to population ratio(%) in Malawi in 2002 to that in 2007?
Make the answer very short. 1.09. What is the ratio of the Employment to population ratio(%) in South Africa in 2002 to that in 2007?
Give a very brief answer. 0.88. What is the ratio of the Employment to population ratio(%) of Georgia in 2003 to that in 2004?
Your response must be concise. 1.24. What is the ratio of the Employment to population ratio(%) of Guatemala in 2003 to that in 2004?
Your answer should be compact. 1.01. What is the ratio of the Employment to population ratio(%) in Malawi in 2003 to that in 2004?
Make the answer very short. 0.95. What is the ratio of the Employment to population ratio(%) of Georgia in 2003 to that in 2005?
Ensure brevity in your answer.  1.18. What is the ratio of the Employment to population ratio(%) of Guatemala in 2003 to that in 2005?
Give a very brief answer. 0.98. What is the ratio of the Employment to population ratio(%) in Malawi in 2003 to that in 2005?
Provide a short and direct response. 0.91. What is the ratio of the Employment to population ratio(%) in South Africa in 2003 to that in 2005?
Keep it short and to the point. 0.84. What is the ratio of the Employment to population ratio(%) of Georgia in 2003 to that in 2006?
Offer a terse response. 1.22. What is the ratio of the Employment to population ratio(%) of Guatemala in 2003 to that in 2006?
Your answer should be very brief. 0.95. What is the ratio of the Employment to population ratio(%) in Malawi in 2003 to that in 2006?
Give a very brief answer. 1.01. What is the ratio of the Employment to population ratio(%) in South Africa in 2003 to that in 2006?
Provide a short and direct response. 0.82. What is the ratio of the Employment to population ratio(%) in Georgia in 2003 to that in 2007?
Give a very brief answer. 1.24. What is the ratio of the Employment to population ratio(%) of Guatemala in 2003 to that in 2007?
Offer a very short reply. 0.97. What is the ratio of the Employment to population ratio(%) of Malawi in 2003 to that in 2007?
Ensure brevity in your answer.  1.15. What is the ratio of the Employment to population ratio(%) in South Africa in 2003 to that in 2007?
Make the answer very short. 0.8. What is the ratio of the Employment to population ratio(%) of Georgia in 2004 to that in 2005?
Provide a succinct answer. 0.96. What is the ratio of the Employment to population ratio(%) of Guatemala in 2004 to that in 2005?
Provide a succinct answer. 0.97. What is the ratio of the Employment to population ratio(%) of Malawi in 2004 to that in 2005?
Your answer should be compact. 0.96. What is the ratio of the Employment to population ratio(%) in South Africa in 2004 to that in 2005?
Provide a succinct answer. 0.9. What is the ratio of the Employment to population ratio(%) in Georgia in 2004 to that in 2006?
Provide a short and direct response. 0.99. What is the ratio of the Employment to population ratio(%) in Guatemala in 2004 to that in 2006?
Keep it short and to the point. 0.95. What is the ratio of the Employment to population ratio(%) in Malawi in 2004 to that in 2006?
Keep it short and to the point. 1.06. What is the ratio of the Employment to population ratio(%) of South Africa in 2004 to that in 2006?
Offer a terse response. 0.88. What is the ratio of the Employment to population ratio(%) of Guatemala in 2004 to that in 2007?
Give a very brief answer. 0.97. What is the ratio of the Employment to population ratio(%) of Malawi in 2004 to that in 2007?
Offer a very short reply. 1.21. What is the ratio of the Employment to population ratio(%) in Georgia in 2005 to that in 2006?
Provide a short and direct response. 1.03. What is the ratio of the Employment to population ratio(%) of Guatemala in 2005 to that in 2006?
Your answer should be compact. 0.97. What is the ratio of the Employment to population ratio(%) of Malawi in 2005 to that in 2006?
Your answer should be very brief. 1.11. What is the ratio of the Employment to population ratio(%) in South Africa in 2005 to that in 2006?
Your response must be concise. 0.97. What is the ratio of the Employment to population ratio(%) in Georgia in 2005 to that in 2007?
Your response must be concise. 1.05. What is the ratio of the Employment to population ratio(%) in Malawi in 2005 to that in 2007?
Keep it short and to the point. 1.26. What is the ratio of the Employment to population ratio(%) of South Africa in 2005 to that in 2007?
Provide a short and direct response. 0.95. What is the ratio of the Employment to population ratio(%) of Georgia in 2006 to that in 2007?
Ensure brevity in your answer.  1.01. What is the ratio of the Employment to population ratio(%) in Guatemala in 2006 to that in 2007?
Offer a terse response. 1.02. What is the ratio of the Employment to population ratio(%) in Malawi in 2006 to that in 2007?
Provide a succinct answer. 1.14. What is the ratio of the Employment to population ratio(%) of South Africa in 2006 to that in 2007?
Offer a very short reply. 0.97. What is the difference between the highest and the second highest Employment to population ratio(%) in Georgia?
Your response must be concise. 0.1. What is the difference between the highest and the second highest Employment to population ratio(%) in South Africa?
Give a very brief answer. 0.2. What is the difference between the highest and the lowest Employment to population ratio(%) of Georgia?
Make the answer very short. 6.7. 